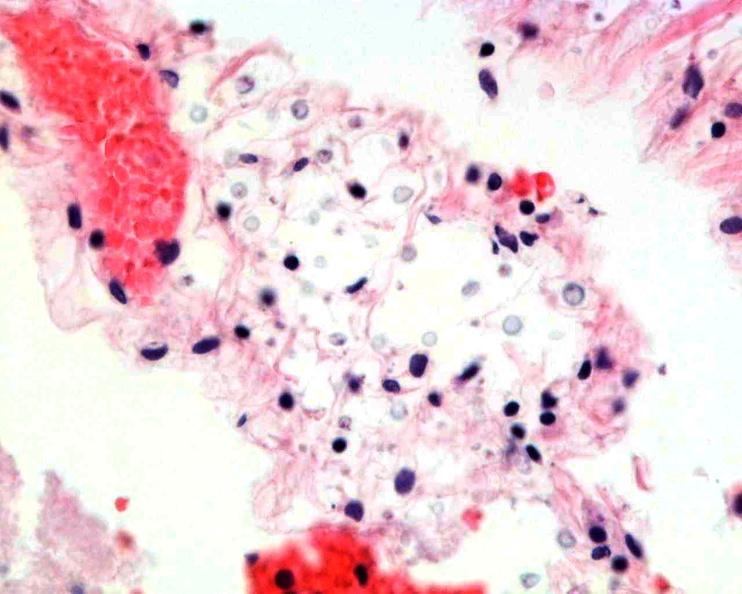s large gland present?
Answer the question using a single word or phrase. No 